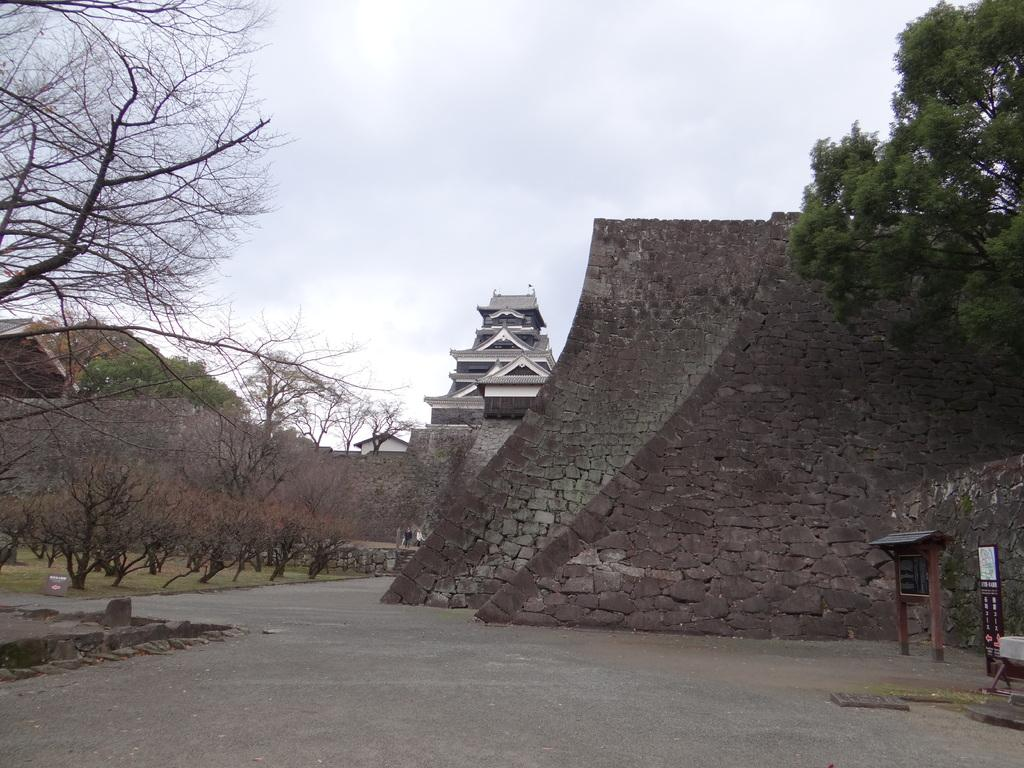What type of structures can be seen in the image? There are buildings in the image. What architectural elements are present in the image? There are walls in the image. What type of vegetation is visible in the image? There are trees in the image. What other objects can be seen in the image? There are boards in the image. What is visible in the background of the image? The sky is visible in the background of the image. How many eggs are being raked in the image? There are no eggs or rakes present in the image. What time of day is depicted in the image? The provided facts do not mention the time of day, so it cannot be determined from the image. 